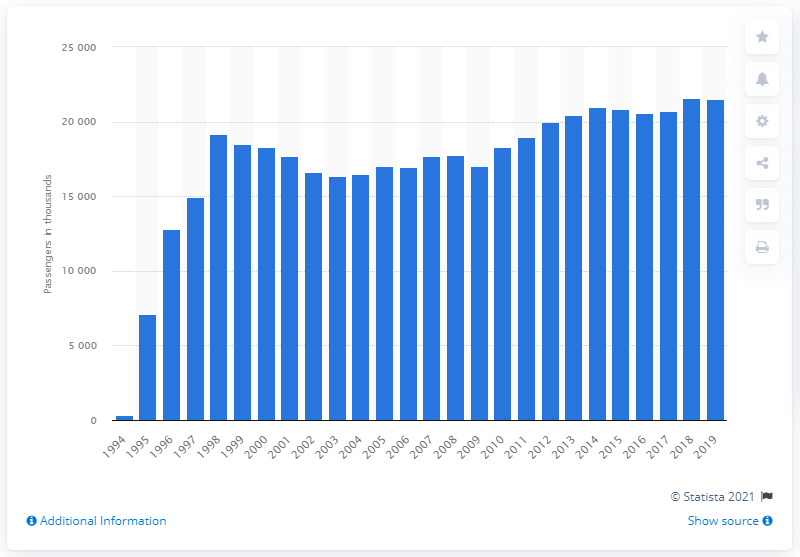Point out several critical features in this image. The Channel Tunnel, also known as the Chunnel, was opened in the year 1994. 